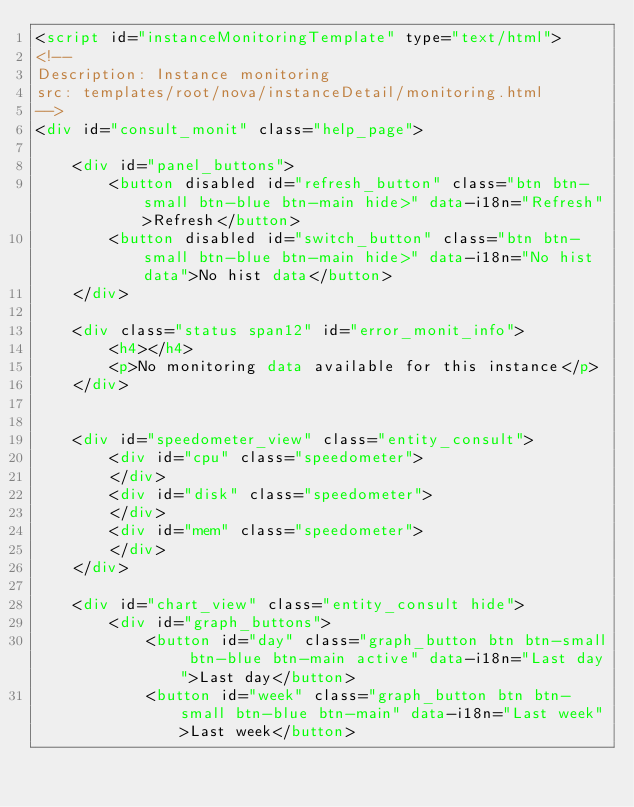Convert code to text. <code><loc_0><loc_0><loc_500><loc_500><_HTML_><script id="instanceMonitoringTemplate" type="text/html">
<!--
Description: Instance monitoring
src: templates/root/nova/instanceDetail/monitoring.html
-->
<div id="consult_monit" class="help_page">

	<div id="panel_buttons">
		<button disabled id="refresh_button" class="btn btn-small btn-blue btn-main hide>" data-i18n="Refresh">Refresh</button>
		<button disabled id="switch_button" class="btn btn-small btn-blue btn-main hide>" data-i18n="No hist data">No hist data</button>
	</div>

	<div class="status span12" id="error_monit_info">
		<h4></h4>
	    <p>No monitoring data available for this instance</p>
	</div>
	

    <div id="speedometer_view" class="entity_consult">
		<div id="cpu" class="speedometer">
		</div>
		<div id="disk" class="speedometer">
		</div>
		<div id="mem" class="speedometer">
		</div>
	</div>

	<div id="chart_view" class="entity_consult hide">
		<div id="graph_buttons">
			<button id="day" class="graph_button btn btn-small btn-blue btn-main active" data-i18n="Last day">Last day</button>
			<button id="week" class="graph_button btn btn-small btn-blue btn-main" data-i18n="Last week">Last week</button></code> 